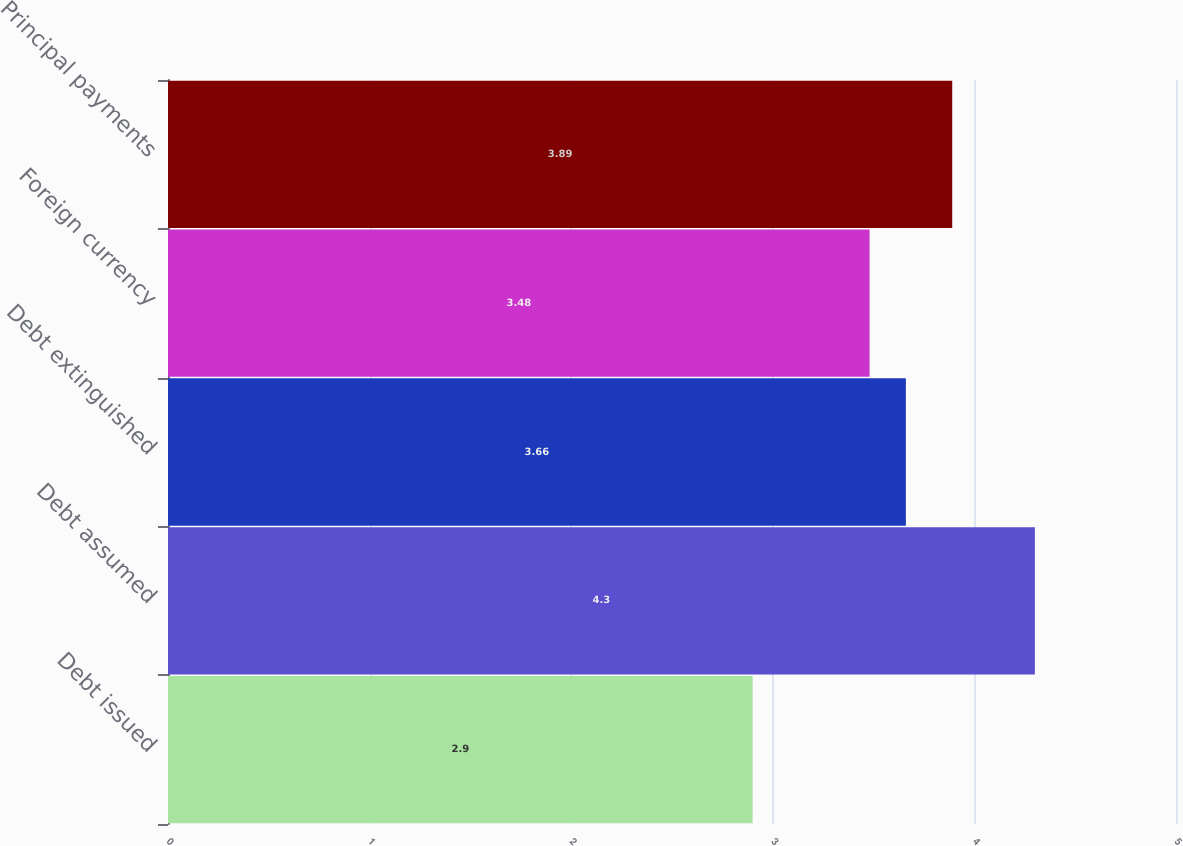Convert chart. <chart><loc_0><loc_0><loc_500><loc_500><bar_chart><fcel>Debt issued<fcel>Debt assumed<fcel>Debt extinguished<fcel>Foreign currency<fcel>Principal payments<nl><fcel>2.9<fcel>4.3<fcel>3.66<fcel>3.48<fcel>3.89<nl></chart> 